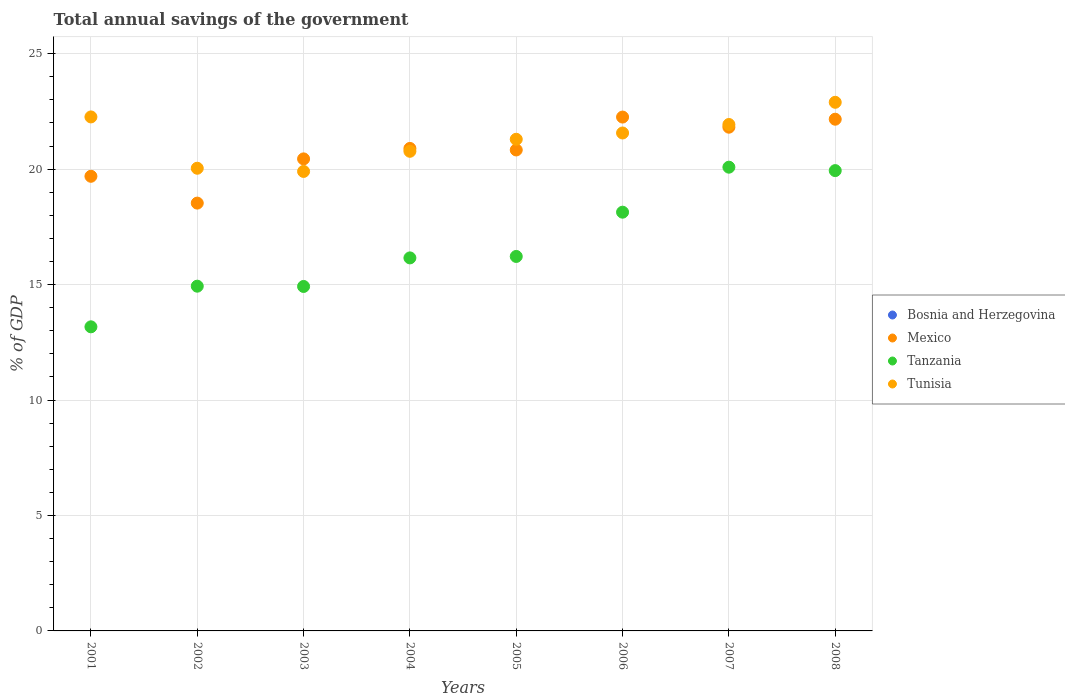How many different coloured dotlines are there?
Offer a terse response. 3. Is the number of dotlines equal to the number of legend labels?
Provide a succinct answer. No. What is the total annual savings of the government in Tanzania in 2004?
Keep it short and to the point. 16.16. Across all years, what is the maximum total annual savings of the government in Tunisia?
Your response must be concise. 22.89. Across all years, what is the minimum total annual savings of the government in Bosnia and Herzegovina?
Make the answer very short. 0. In which year was the total annual savings of the government in Mexico maximum?
Keep it short and to the point. 2006. What is the total total annual savings of the government in Tunisia in the graph?
Offer a very short reply. 170.66. What is the difference between the total annual savings of the government in Mexico in 2003 and that in 2004?
Keep it short and to the point. -0.45. What is the difference between the total annual savings of the government in Tanzania in 2002 and the total annual savings of the government in Mexico in 2001?
Make the answer very short. -4.76. What is the average total annual savings of the government in Mexico per year?
Your answer should be compact. 20.83. In the year 2006, what is the difference between the total annual savings of the government in Tanzania and total annual savings of the government in Tunisia?
Your response must be concise. -3.43. What is the ratio of the total annual savings of the government in Tunisia in 2007 to that in 2008?
Your response must be concise. 0.96. What is the difference between the highest and the second highest total annual savings of the government in Mexico?
Offer a terse response. 0.09. What is the difference between the highest and the lowest total annual savings of the government in Mexico?
Ensure brevity in your answer.  3.73. Is it the case that in every year, the sum of the total annual savings of the government in Mexico and total annual savings of the government in Tunisia  is greater than the total annual savings of the government in Tanzania?
Offer a very short reply. Yes. Is the total annual savings of the government in Tanzania strictly less than the total annual savings of the government in Tunisia over the years?
Provide a succinct answer. Yes. How many years are there in the graph?
Keep it short and to the point. 8. Are the values on the major ticks of Y-axis written in scientific E-notation?
Offer a terse response. No. Does the graph contain grids?
Your answer should be compact. Yes. Where does the legend appear in the graph?
Ensure brevity in your answer.  Center right. What is the title of the graph?
Ensure brevity in your answer.  Total annual savings of the government. Does "Caribbean small states" appear as one of the legend labels in the graph?
Your response must be concise. No. What is the label or title of the X-axis?
Your response must be concise. Years. What is the label or title of the Y-axis?
Make the answer very short. % of GDP. What is the % of GDP of Mexico in 2001?
Provide a succinct answer. 19.69. What is the % of GDP in Tanzania in 2001?
Your answer should be compact. 13.17. What is the % of GDP of Tunisia in 2001?
Make the answer very short. 22.26. What is the % of GDP in Bosnia and Herzegovina in 2002?
Give a very brief answer. 0. What is the % of GDP in Mexico in 2002?
Give a very brief answer. 18.53. What is the % of GDP in Tanzania in 2002?
Offer a terse response. 14.93. What is the % of GDP of Tunisia in 2002?
Your answer should be very brief. 20.04. What is the % of GDP of Bosnia and Herzegovina in 2003?
Your answer should be very brief. 0. What is the % of GDP of Mexico in 2003?
Offer a terse response. 20.44. What is the % of GDP of Tanzania in 2003?
Your answer should be compact. 14.92. What is the % of GDP in Tunisia in 2003?
Your response must be concise. 19.9. What is the % of GDP of Bosnia and Herzegovina in 2004?
Provide a short and direct response. 0. What is the % of GDP of Mexico in 2004?
Your response must be concise. 20.9. What is the % of GDP of Tanzania in 2004?
Your answer should be very brief. 16.16. What is the % of GDP in Tunisia in 2004?
Offer a very short reply. 20.77. What is the % of GDP in Bosnia and Herzegovina in 2005?
Your response must be concise. 0. What is the % of GDP in Mexico in 2005?
Give a very brief answer. 20.83. What is the % of GDP of Tanzania in 2005?
Ensure brevity in your answer.  16.22. What is the % of GDP of Tunisia in 2005?
Offer a very short reply. 21.29. What is the % of GDP of Bosnia and Herzegovina in 2006?
Provide a succinct answer. 0. What is the % of GDP in Mexico in 2006?
Your answer should be compact. 22.25. What is the % of GDP of Tanzania in 2006?
Provide a short and direct response. 18.13. What is the % of GDP of Tunisia in 2006?
Your answer should be very brief. 21.56. What is the % of GDP in Mexico in 2007?
Offer a very short reply. 21.82. What is the % of GDP in Tanzania in 2007?
Your response must be concise. 20.08. What is the % of GDP in Tunisia in 2007?
Provide a short and direct response. 21.93. What is the % of GDP of Mexico in 2008?
Offer a terse response. 22.16. What is the % of GDP in Tanzania in 2008?
Make the answer very short. 19.94. What is the % of GDP of Tunisia in 2008?
Provide a succinct answer. 22.89. Across all years, what is the maximum % of GDP of Mexico?
Your answer should be compact. 22.25. Across all years, what is the maximum % of GDP of Tanzania?
Your response must be concise. 20.08. Across all years, what is the maximum % of GDP in Tunisia?
Offer a very short reply. 22.89. Across all years, what is the minimum % of GDP of Mexico?
Give a very brief answer. 18.53. Across all years, what is the minimum % of GDP in Tanzania?
Provide a short and direct response. 13.17. Across all years, what is the minimum % of GDP in Tunisia?
Offer a very short reply. 19.9. What is the total % of GDP of Bosnia and Herzegovina in the graph?
Give a very brief answer. 0. What is the total % of GDP of Mexico in the graph?
Your answer should be very brief. 166.62. What is the total % of GDP of Tanzania in the graph?
Offer a very short reply. 133.55. What is the total % of GDP of Tunisia in the graph?
Your answer should be compact. 170.66. What is the difference between the % of GDP of Mexico in 2001 and that in 2002?
Your answer should be very brief. 1.16. What is the difference between the % of GDP in Tanzania in 2001 and that in 2002?
Your answer should be compact. -1.76. What is the difference between the % of GDP in Tunisia in 2001 and that in 2002?
Provide a short and direct response. 2.22. What is the difference between the % of GDP of Mexico in 2001 and that in 2003?
Make the answer very short. -0.75. What is the difference between the % of GDP in Tanzania in 2001 and that in 2003?
Your answer should be compact. -1.75. What is the difference between the % of GDP in Tunisia in 2001 and that in 2003?
Keep it short and to the point. 2.36. What is the difference between the % of GDP of Mexico in 2001 and that in 2004?
Keep it short and to the point. -1.21. What is the difference between the % of GDP of Tanzania in 2001 and that in 2004?
Provide a succinct answer. -2.99. What is the difference between the % of GDP of Tunisia in 2001 and that in 2004?
Offer a terse response. 1.49. What is the difference between the % of GDP in Mexico in 2001 and that in 2005?
Your answer should be very brief. -1.14. What is the difference between the % of GDP in Tanzania in 2001 and that in 2005?
Your answer should be very brief. -3.05. What is the difference between the % of GDP of Tunisia in 2001 and that in 2005?
Give a very brief answer. 0.97. What is the difference between the % of GDP of Mexico in 2001 and that in 2006?
Provide a succinct answer. -2.56. What is the difference between the % of GDP of Tanzania in 2001 and that in 2006?
Offer a terse response. -4.96. What is the difference between the % of GDP in Tunisia in 2001 and that in 2006?
Keep it short and to the point. 0.7. What is the difference between the % of GDP in Mexico in 2001 and that in 2007?
Your answer should be very brief. -2.13. What is the difference between the % of GDP in Tanzania in 2001 and that in 2007?
Your response must be concise. -6.91. What is the difference between the % of GDP in Tunisia in 2001 and that in 2007?
Your response must be concise. 0.33. What is the difference between the % of GDP of Mexico in 2001 and that in 2008?
Provide a short and direct response. -2.47. What is the difference between the % of GDP of Tanzania in 2001 and that in 2008?
Offer a very short reply. -6.77. What is the difference between the % of GDP of Tunisia in 2001 and that in 2008?
Offer a terse response. -0.63. What is the difference between the % of GDP of Mexico in 2002 and that in 2003?
Your answer should be very brief. -1.92. What is the difference between the % of GDP of Tanzania in 2002 and that in 2003?
Offer a very short reply. 0.01. What is the difference between the % of GDP of Tunisia in 2002 and that in 2003?
Offer a very short reply. 0.14. What is the difference between the % of GDP in Mexico in 2002 and that in 2004?
Provide a short and direct response. -2.37. What is the difference between the % of GDP in Tanzania in 2002 and that in 2004?
Your answer should be very brief. -1.22. What is the difference between the % of GDP of Tunisia in 2002 and that in 2004?
Make the answer very short. -0.73. What is the difference between the % of GDP in Mexico in 2002 and that in 2005?
Keep it short and to the point. -2.3. What is the difference between the % of GDP of Tanzania in 2002 and that in 2005?
Offer a very short reply. -1.29. What is the difference between the % of GDP in Tunisia in 2002 and that in 2005?
Offer a very short reply. -1.25. What is the difference between the % of GDP in Mexico in 2002 and that in 2006?
Give a very brief answer. -3.73. What is the difference between the % of GDP in Tanzania in 2002 and that in 2006?
Provide a short and direct response. -3.2. What is the difference between the % of GDP of Tunisia in 2002 and that in 2006?
Provide a short and direct response. -1.53. What is the difference between the % of GDP of Mexico in 2002 and that in 2007?
Offer a very short reply. -3.29. What is the difference between the % of GDP of Tanzania in 2002 and that in 2007?
Make the answer very short. -5.15. What is the difference between the % of GDP of Tunisia in 2002 and that in 2007?
Your response must be concise. -1.89. What is the difference between the % of GDP of Mexico in 2002 and that in 2008?
Ensure brevity in your answer.  -3.63. What is the difference between the % of GDP in Tanzania in 2002 and that in 2008?
Offer a terse response. -5.01. What is the difference between the % of GDP of Tunisia in 2002 and that in 2008?
Your response must be concise. -2.86. What is the difference between the % of GDP in Mexico in 2003 and that in 2004?
Keep it short and to the point. -0.45. What is the difference between the % of GDP of Tanzania in 2003 and that in 2004?
Offer a very short reply. -1.24. What is the difference between the % of GDP in Tunisia in 2003 and that in 2004?
Offer a terse response. -0.87. What is the difference between the % of GDP in Mexico in 2003 and that in 2005?
Offer a very short reply. -0.39. What is the difference between the % of GDP in Tanzania in 2003 and that in 2005?
Your answer should be compact. -1.3. What is the difference between the % of GDP in Tunisia in 2003 and that in 2005?
Your answer should be very brief. -1.39. What is the difference between the % of GDP of Mexico in 2003 and that in 2006?
Your answer should be compact. -1.81. What is the difference between the % of GDP of Tanzania in 2003 and that in 2006?
Provide a short and direct response. -3.22. What is the difference between the % of GDP in Tunisia in 2003 and that in 2006?
Offer a very short reply. -1.66. What is the difference between the % of GDP of Mexico in 2003 and that in 2007?
Provide a short and direct response. -1.37. What is the difference between the % of GDP of Tanzania in 2003 and that in 2007?
Your answer should be very brief. -5.17. What is the difference between the % of GDP of Tunisia in 2003 and that in 2007?
Provide a succinct answer. -2.03. What is the difference between the % of GDP of Mexico in 2003 and that in 2008?
Your response must be concise. -1.72. What is the difference between the % of GDP in Tanzania in 2003 and that in 2008?
Offer a terse response. -5.02. What is the difference between the % of GDP of Tunisia in 2003 and that in 2008?
Keep it short and to the point. -2.99. What is the difference between the % of GDP in Mexico in 2004 and that in 2005?
Your response must be concise. 0.07. What is the difference between the % of GDP of Tanzania in 2004 and that in 2005?
Your response must be concise. -0.06. What is the difference between the % of GDP of Tunisia in 2004 and that in 2005?
Provide a short and direct response. -0.52. What is the difference between the % of GDP in Mexico in 2004 and that in 2006?
Provide a succinct answer. -1.36. What is the difference between the % of GDP of Tanzania in 2004 and that in 2006?
Your answer should be very brief. -1.98. What is the difference between the % of GDP of Tunisia in 2004 and that in 2006?
Your response must be concise. -0.79. What is the difference between the % of GDP of Mexico in 2004 and that in 2007?
Provide a succinct answer. -0.92. What is the difference between the % of GDP of Tanzania in 2004 and that in 2007?
Offer a terse response. -3.93. What is the difference between the % of GDP in Tunisia in 2004 and that in 2007?
Ensure brevity in your answer.  -1.16. What is the difference between the % of GDP in Mexico in 2004 and that in 2008?
Your response must be concise. -1.27. What is the difference between the % of GDP in Tanzania in 2004 and that in 2008?
Your response must be concise. -3.78. What is the difference between the % of GDP in Tunisia in 2004 and that in 2008?
Your answer should be very brief. -2.12. What is the difference between the % of GDP of Mexico in 2005 and that in 2006?
Give a very brief answer. -1.42. What is the difference between the % of GDP in Tanzania in 2005 and that in 2006?
Keep it short and to the point. -1.92. What is the difference between the % of GDP of Tunisia in 2005 and that in 2006?
Provide a short and direct response. -0.27. What is the difference between the % of GDP of Mexico in 2005 and that in 2007?
Provide a succinct answer. -0.99. What is the difference between the % of GDP in Tanzania in 2005 and that in 2007?
Make the answer very short. -3.87. What is the difference between the % of GDP of Tunisia in 2005 and that in 2007?
Your response must be concise. -0.64. What is the difference between the % of GDP in Mexico in 2005 and that in 2008?
Provide a short and direct response. -1.33. What is the difference between the % of GDP in Tanzania in 2005 and that in 2008?
Your response must be concise. -3.72. What is the difference between the % of GDP in Tunisia in 2005 and that in 2008?
Offer a terse response. -1.6. What is the difference between the % of GDP in Mexico in 2006 and that in 2007?
Give a very brief answer. 0.44. What is the difference between the % of GDP in Tanzania in 2006 and that in 2007?
Provide a succinct answer. -1.95. What is the difference between the % of GDP of Tunisia in 2006 and that in 2007?
Give a very brief answer. -0.37. What is the difference between the % of GDP in Mexico in 2006 and that in 2008?
Offer a terse response. 0.09. What is the difference between the % of GDP in Tanzania in 2006 and that in 2008?
Ensure brevity in your answer.  -1.8. What is the difference between the % of GDP in Tunisia in 2006 and that in 2008?
Your answer should be compact. -1.33. What is the difference between the % of GDP of Mexico in 2007 and that in 2008?
Ensure brevity in your answer.  -0.35. What is the difference between the % of GDP in Tanzania in 2007 and that in 2008?
Your answer should be very brief. 0.15. What is the difference between the % of GDP in Tunisia in 2007 and that in 2008?
Offer a very short reply. -0.96. What is the difference between the % of GDP of Mexico in 2001 and the % of GDP of Tanzania in 2002?
Your answer should be very brief. 4.76. What is the difference between the % of GDP of Mexico in 2001 and the % of GDP of Tunisia in 2002?
Keep it short and to the point. -0.35. What is the difference between the % of GDP in Tanzania in 2001 and the % of GDP in Tunisia in 2002?
Your response must be concise. -6.87. What is the difference between the % of GDP of Mexico in 2001 and the % of GDP of Tanzania in 2003?
Keep it short and to the point. 4.77. What is the difference between the % of GDP in Mexico in 2001 and the % of GDP in Tunisia in 2003?
Provide a succinct answer. -0.21. What is the difference between the % of GDP in Tanzania in 2001 and the % of GDP in Tunisia in 2003?
Your answer should be compact. -6.73. What is the difference between the % of GDP in Mexico in 2001 and the % of GDP in Tanzania in 2004?
Ensure brevity in your answer.  3.53. What is the difference between the % of GDP of Mexico in 2001 and the % of GDP of Tunisia in 2004?
Make the answer very short. -1.08. What is the difference between the % of GDP in Tanzania in 2001 and the % of GDP in Tunisia in 2004?
Provide a short and direct response. -7.6. What is the difference between the % of GDP of Mexico in 2001 and the % of GDP of Tanzania in 2005?
Provide a succinct answer. 3.47. What is the difference between the % of GDP in Mexico in 2001 and the % of GDP in Tunisia in 2005?
Provide a short and direct response. -1.6. What is the difference between the % of GDP of Tanzania in 2001 and the % of GDP of Tunisia in 2005?
Keep it short and to the point. -8.12. What is the difference between the % of GDP of Mexico in 2001 and the % of GDP of Tanzania in 2006?
Offer a very short reply. 1.55. What is the difference between the % of GDP of Mexico in 2001 and the % of GDP of Tunisia in 2006?
Offer a terse response. -1.88. What is the difference between the % of GDP of Tanzania in 2001 and the % of GDP of Tunisia in 2006?
Keep it short and to the point. -8.39. What is the difference between the % of GDP in Mexico in 2001 and the % of GDP in Tanzania in 2007?
Offer a terse response. -0.39. What is the difference between the % of GDP in Mexico in 2001 and the % of GDP in Tunisia in 2007?
Your answer should be very brief. -2.24. What is the difference between the % of GDP in Tanzania in 2001 and the % of GDP in Tunisia in 2007?
Ensure brevity in your answer.  -8.76. What is the difference between the % of GDP of Mexico in 2001 and the % of GDP of Tanzania in 2008?
Your answer should be compact. -0.25. What is the difference between the % of GDP in Mexico in 2001 and the % of GDP in Tunisia in 2008?
Your response must be concise. -3.2. What is the difference between the % of GDP in Tanzania in 2001 and the % of GDP in Tunisia in 2008?
Your response must be concise. -9.72. What is the difference between the % of GDP of Mexico in 2002 and the % of GDP of Tanzania in 2003?
Keep it short and to the point. 3.61. What is the difference between the % of GDP in Mexico in 2002 and the % of GDP in Tunisia in 2003?
Keep it short and to the point. -1.37. What is the difference between the % of GDP of Tanzania in 2002 and the % of GDP of Tunisia in 2003?
Your response must be concise. -4.97. What is the difference between the % of GDP of Mexico in 2002 and the % of GDP of Tanzania in 2004?
Give a very brief answer. 2.37. What is the difference between the % of GDP in Mexico in 2002 and the % of GDP in Tunisia in 2004?
Offer a terse response. -2.24. What is the difference between the % of GDP in Tanzania in 2002 and the % of GDP in Tunisia in 2004?
Your answer should be compact. -5.84. What is the difference between the % of GDP of Mexico in 2002 and the % of GDP of Tanzania in 2005?
Offer a terse response. 2.31. What is the difference between the % of GDP of Mexico in 2002 and the % of GDP of Tunisia in 2005?
Your response must be concise. -2.76. What is the difference between the % of GDP in Tanzania in 2002 and the % of GDP in Tunisia in 2005?
Offer a terse response. -6.36. What is the difference between the % of GDP in Mexico in 2002 and the % of GDP in Tanzania in 2006?
Keep it short and to the point. 0.39. What is the difference between the % of GDP of Mexico in 2002 and the % of GDP of Tunisia in 2006?
Ensure brevity in your answer.  -3.04. What is the difference between the % of GDP in Tanzania in 2002 and the % of GDP in Tunisia in 2006?
Make the answer very short. -6.63. What is the difference between the % of GDP in Mexico in 2002 and the % of GDP in Tanzania in 2007?
Give a very brief answer. -1.56. What is the difference between the % of GDP in Mexico in 2002 and the % of GDP in Tunisia in 2007?
Provide a short and direct response. -3.4. What is the difference between the % of GDP of Tanzania in 2002 and the % of GDP of Tunisia in 2007?
Offer a very short reply. -7. What is the difference between the % of GDP in Mexico in 2002 and the % of GDP in Tanzania in 2008?
Provide a short and direct response. -1.41. What is the difference between the % of GDP of Mexico in 2002 and the % of GDP of Tunisia in 2008?
Give a very brief answer. -4.37. What is the difference between the % of GDP of Tanzania in 2002 and the % of GDP of Tunisia in 2008?
Provide a short and direct response. -7.96. What is the difference between the % of GDP of Mexico in 2003 and the % of GDP of Tanzania in 2004?
Keep it short and to the point. 4.29. What is the difference between the % of GDP of Mexico in 2003 and the % of GDP of Tunisia in 2004?
Your answer should be compact. -0.33. What is the difference between the % of GDP of Tanzania in 2003 and the % of GDP of Tunisia in 2004?
Give a very brief answer. -5.85. What is the difference between the % of GDP in Mexico in 2003 and the % of GDP in Tanzania in 2005?
Offer a terse response. 4.23. What is the difference between the % of GDP in Mexico in 2003 and the % of GDP in Tunisia in 2005?
Give a very brief answer. -0.85. What is the difference between the % of GDP of Tanzania in 2003 and the % of GDP of Tunisia in 2005?
Ensure brevity in your answer.  -6.37. What is the difference between the % of GDP in Mexico in 2003 and the % of GDP in Tanzania in 2006?
Your answer should be compact. 2.31. What is the difference between the % of GDP in Mexico in 2003 and the % of GDP in Tunisia in 2006?
Offer a terse response. -1.12. What is the difference between the % of GDP in Tanzania in 2003 and the % of GDP in Tunisia in 2006?
Ensure brevity in your answer.  -6.65. What is the difference between the % of GDP in Mexico in 2003 and the % of GDP in Tanzania in 2007?
Make the answer very short. 0.36. What is the difference between the % of GDP in Mexico in 2003 and the % of GDP in Tunisia in 2007?
Offer a terse response. -1.49. What is the difference between the % of GDP of Tanzania in 2003 and the % of GDP of Tunisia in 2007?
Your answer should be compact. -7.01. What is the difference between the % of GDP in Mexico in 2003 and the % of GDP in Tanzania in 2008?
Your response must be concise. 0.51. What is the difference between the % of GDP of Mexico in 2003 and the % of GDP of Tunisia in 2008?
Provide a succinct answer. -2.45. What is the difference between the % of GDP in Tanzania in 2003 and the % of GDP in Tunisia in 2008?
Keep it short and to the point. -7.98. What is the difference between the % of GDP in Mexico in 2004 and the % of GDP in Tanzania in 2005?
Offer a terse response. 4.68. What is the difference between the % of GDP of Mexico in 2004 and the % of GDP of Tunisia in 2005?
Your answer should be compact. -0.4. What is the difference between the % of GDP of Tanzania in 2004 and the % of GDP of Tunisia in 2005?
Give a very brief answer. -5.14. What is the difference between the % of GDP in Mexico in 2004 and the % of GDP in Tanzania in 2006?
Make the answer very short. 2.76. What is the difference between the % of GDP in Mexico in 2004 and the % of GDP in Tunisia in 2006?
Your response must be concise. -0.67. What is the difference between the % of GDP of Tanzania in 2004 and the % of GDP of Tunisia in 2006?
Make the answer very short. -5.41. What is the difference between the % of GDP in Mexico in 2004 and the % of GDP in Tanzania in 2007?
Your response must be concise. 0.81. What is the difference between the % of GDP in Mexico in 2004 and the % of GDP in Tunisia in 2007?
Offer a terse response. -1.04. What is the difference between the % of GDP of Tanzania in 2004 and the % of GDP of Tunisia in 2007?
Make the answer very short. -5.78. What is the difference between the % of GDP of Mexico in 2004 and the % of GDP of Tanzania in 2008?
Give a very brief answer. 0.96. What is the difference between the % of GDP of Mexico in 2004 and the % of GDP of Tunisia in 2008?
Provide a succinct answer. -2. What is the difference between the % of GDP in Tanzania in 2004 and the % of GDP in Tunisia in 2008?
Offer a terse response. -6.74. What is the difference between the % of GDP of Mexico in 2005 and the % of GDP of Tanzania in 2006?
Provide a succinct answer. 2.7. What is the difference between the % of GDP in Mexico in 2005 and the % of GDP in Tunisia in 2006?
Ensure brevity in your answer.  -0.73. What is the difference between the % of GDP of Tanzania in 2005 and the % of GDP of Tunisia in 2006?
Your answer should be compact. -5.35. What is the difference between the % of GDP in Mexico in 2005 and the % of GDP in Tanzania in 2007?
Provide a short and direct response. 0.75. What is the difference between the % of GDP of Mexico in 2005 and the % of GDP of Tunisia in 2007?
Keep it short and to the point. -1.1. What is the difference between the % of GDP of Tanzania in 2005 and the % of GDP of Tunisia in 2007?
Offer a terse response. -5.71. What is the difference between the % of GDP in Mexico in 2005 and the % of GDP in Tanzania in 2008?
Give a very brief answer. 0.89. What is the difference between the % of GDP of Mexico in 2005 and the % of GDP of Tunisia in 2008?
Give a very brief answer. -2.06. What is the difference between the % of GDP of Tanzania in 2005 and the % of GDP of Tunisia in 2008?
Offer a very short reply. -6.68. What is the difference between the % of GDP of Mexico in 2006 and the % of GDP of Tanzania in 2007?
Your answer should be compact. 2.17. What is the difference between the % of GDP of Mexico in 2006 and the % of GDP of Tunisia in 2007?
Offer a very short reply. 0.32. What is the difference between the % of GDP in Tanzania in 2006 and the % of GDP in Tunisia in 2007?
Your answer should be compact. -3.8. What is the difference between the % of GDP in Mexico in 2006 and the % of GDP in Tanzania in 2008?
Provide a succinct answer. 2.32. What is the difference between the % of GDP in Mexico in 2006 and the % of GDP in Tunisia in 2008?
Offer a very short reply. -0.64. What is the difference between the % of GDP in Tanzania in 2006 and the % of GDP in Tunisia in 2008?
Make the answer very short. -4.76. What is the difference between the % of GDP of Mexico in 2007 and the % of GDP of Tanzania in 2008?
Offer a very short reply. 1.88. What is the difference between the % of GDP in Mexico in 2007 and the % of GDP in Tunisia in 2008?
Offer a terse response. -1.08. What is the difference between the % of GDP of Tanzania in 2007 and the % of GDP of Tunisia in 2008?
Provide a succinct answer. -2.81. What is the average % of GDP in Mexico per year?
Offer a very short reply. 20.83. What is the average % of GDP in Tanzania per year?
Provide a short and direct response. 16.69. What is the average % of GDP of Tunisia per year?
Make the answer very short. 21.33. In the year 2001, what is the difference between the % of GDP in Mexico and % of GDP in Tanzania?
Give a very brief answer. 6.52. In the year 2001, what is the difference between the % of GDP of Mexico and % of GDP of Tunisia?
Your answer should be compact. -2.57. In the year 2001, what is the difference between the % of GDP in Tanzania and % of GDP in Tunisia?
Keep it short and to the point. -9.09. In the year 2002, what is the difference between the % of GDP of Mexico and % of GDP of Tanzania?
Your response must be concise. 3.6. In the year 2002, what is the difference between the % of GDP in Mexico and % of GDP in Tunisia?
Your answer should be very brief. -1.51. In the year 2002, what is the difference between the % of GDP in Tanzania and % of GDP in Tunisia?
Offer a terse response. -5.11. In the year 2003, what is the difference between the % of GDP of Mexico and % of GDP of Tanzania?
Give a very brief answer. 5.53. In the year 2003, what is the difference between the % of GDP of Mexico and % of GDP of Tunisia?
Ensure brevity in your answer.  0.54. In the year 2003, what is the difference between the % of GDP in Tanzania and % of GDP in Tunisia?
Make the answer very short. -4.98. In the year 2004, what is the difference between the % of GDP in Mexico and % of GDP in Tanzania?
Provide a short and direct response. 4.74. In the year 2004, what is the difference between the % of GDP of Mexico and % of GDP of Tunisia?
Your answer should be compact. 0.12. In the year 2004, what is the difference between the % of GDP of Tanzania and % of GDP of Tunisia?
Provide a short and direct response. -4.62. In the year 2005, what is the difference between the % of GDP in Mexico and % of GDP in Tanzania?
Your answer should be very brief. 4.61. In the year 2005, what is the difference between the % of GDP of Mexico and % of GDP of Tunisia?
Your response must be concise. -0.46. In the year 2005, what is the difference between the % of GDP of Tanzania and % of GDP of Tunisia?
Provide a succinct answer. -5.07. In the year 2006, what is the difference between the % of GDP of Mexico and % of GDP of Tanzania?
Your response must be concise. 4.12. In the year 2006, what is the difference between the % of GDP in Mexico and % of GDP in Tunisia?
Your answer should be compact. 0.69. In the year 2006, what is the difference between the % of GDP in Tanzania and % of GDP in Tunisia?
Give a very brief answer. -3.43. In the year 2007, what is the difference between the % of GDP of Mexico and % of GDP of Tanzania?
Offer a terse response. 1.73. In the year 2007, what is the difference between the % of GDP in Mexico and % of GDP in Tunisia?
Offer a terse response. -0.12. In the year 2007, what is the difference between the % of GDP in Tanzania and % of GDP in Tunisia?
Your answer should be very brief. -1.85. In the year 2008, what is the difference between the % of GDP in Mexico and % of GDP in Tanzania?
Provide a succinct answer. 2.23. In the year 2008, what is the difference between the % of GDP of Mexico and % of GDP of Tunisia?
Give a very brief answer. -0.73. In the year 2008, what is the difference between the % of GDP of Tanzania and % of GDP of Tunisia?
Your response must be concise. -2.96. What is the ratio of the % of GDP in Mexico in 2001 to that in 2002?
Keep it short and to the point. 1.06. What is the ratio of the % of GDP in Tanzania in 2001 to that in 2002?
Provide a short and direct response. 0.88. What is the ratio of the % of GDP of Tunisia in 2001 to that in 2002?
Offer a terse response. 1.11. What is the ratio of the % of GDP of Mexico in 2001 to that in 2003?
Your response must be concise. 0.96. What is the ratio of the % of GDP of Tanzania in 2001 to that in 2003?
Offer a terse response. 0.88. What is the ratio of the % of GDP in Tunisia in 2001 to that in 2003?
Your answer should be very brief. 1.12. What is the ratio of the % of GDP in Mexico in 2001 to that in 2004?
Your response must be concise. 0.94. What is the ratio of the % of GDP of Tanzania in 2001 to that in 2004?
Your answer should be very brief. 0.82. What is the ratio of the % of GDP of Tunisia in 2001 to that in 2004?
Ensure brevity in your answer.  1.07. What is the ratio of the % of GDP in Mexico in 2001 to that in 2005?
Your answer should be very brief. 0.95. What is the ratio of the % of GDP of Tanzania in 2001 to that in 2005?
Your response must be concise. 0.81. What is the ratio of the % of GDP of Tunisia in 2001 to that in 2005?
Provide a succinct answer. 1.05. What is the ratio of the % of GDP in Mexico in 2001 to that in 2006?
Provide a short and direct response. 0.88. What is the ratio of the % of GDP in Tanzania in 2001 to that in 2006?
Offer a very short reply. 0.73. What is the ratio of the % of GDP of Tunisia in 2001 to that in 2006?
Ensure brevity in your answer.  1.03. What is the ratio of the % of GDP of Mexico in 2001 to that in 2007?
Make the answer very short. 0.9. What is the ratio of the % of GDP of Tanzania in 2001 to that in 2007?
Your response must be concise. 0.66. What is the ratio of the % of GDP in Mexico in 2001 to that in 2008?
Your response must be concise. 0.89. What is the ratio of the % of GDP in Tanzania in 2001 to that in 2008?
Ensure brevity in your answer.  0.66. What is the ratio of the % of GDP in Tunisia in 2001 to that in 2008?
Your answer should be very brief. 0.97. What is the ratio of the % of GDP in Mexico in 2002 to that in 2003?
Give a very brief answer. 0.91. What is the ratio of the % of GDP of Mexico in 2002 to that in 2004?
Your answer should be very brief. 0.89. What is the ratio of the % of GDP in Tanzania in 2002 to that in 2004?
Make the answer very short. 0.92. What is the ratio of the % of GDP in Tunisia in 2002 to that in 2004?
Give a very brief answer. 0.96. What is the ratio of the % of GDP of Mexico in 2002 to that in 2005?
Your answer should be compact. 0.89. What is the ratio of the % of GDP of Tanzania in 2002 to that in 2005?
Ensure brevity in your answer.  0.92. What is the ratio of the % of GDP in Tunisia in 2002 to that in 2005?
Your answer should be compact. 0.94. What is the ratio of the % of GDP of Mexico in 2002 to that in 2006?
Keep it short and to the point. 0.83. What is the ratio of the % of GDP of Tanzania in 2002 to that in 2006?
Offer a terse response. 0.82. What is the ratio of the % of GDP of Tunisia in 2002 to that in 2006?
Keep it short and to the point. 0.93. What is the ratio of the % of GDP in Mexico in 2002 to that in 2007?
Your answer should be very brief. 0.85. What is the ratio of the % of GDP of Tanzania in 2002 to that in 2007?
Keep it short and to the point. 0.74. What is the ratio of the % of GDP in Tunisia in 2002 to that in 2007?
Provide a short and direct response. 0.91. What is the ratio of the % of GDP in Mexico in 2002 to that in 2008?
Ensure brevity in your answer.  0.84. What is the ratio of the % of GDP in Tanzania in 2002 to that in 2008?
Make the answer very short. 0.75. What is the ratio of the % of GDP of Tunisia in 2002 to that in 2008?
Make the answer very short. 0.88. What is the ratio of the % of GDP in Mexico in 2003 to that in 2004?
Provide a short and direct response. 0.98. What is the ratio of the % of GDP in Tanzania in 2003 to that in 2004?
Ensure brevity in your answer.  0.92. What is the ratio of the % of GDP of Tunisia in 2003 to that in 2004?
Make the answer very short. 0.96. What is the ratio of the % of GDP of Mexico in 2003 to that in 2005?
Provide a succinct answer. 0.98. What is the ratio of the % of GDP of Tanzania in 2003 to that in 2005?
Offer a terse response. 0.92. What is the ratio of the % of GDP of Tunisia in 2003 to that in 2005?
Your answer should be very brief. 0.93. What is the ratio of the % of GDP of Mexico in 2003 to that in 2006?
Make the answer very short. 0.92. What is the ratio of the % of GDP in Tanzania in 2003 to that in 2006?
Offer a very short reply. 0.82. What is the ratio of the % of GDP of Tunisia in 2003 to that in 2006?
Provide a succinct answer. 0.92. What is the ratio of the % of GDP in Mexico in 2003 to that in 2007?
Keep it short and to the point. 0.94. What is the ratio of the % of GDP of Tanzania in 2003 to that in 2007?
Give a very brief answer. 0.74. What is the ratio of the % of GDP of Tunisia in 2003 to that in 2007?
Give a very brief answer. 0.91. What is the ratio of the % of GDP of Mexico in 2003 to that in 2008?
Ensure brevity in your answer.  0.92. What is the ratio of the % of GDP in Tanzania in 2003 to that in 2008?
Make the answer very short. 0.75. What is the ratio of the % of GDP of Tunisia in 2003 to that in 2008?
Provide a short and direct response. 0.87. What is the ratio of the % of GDP in Tanzania in 2004 to that in 2005?
Provide a succinct answer. 1. What is the ratio of the % of GDP in Tunisia in 2004 to that in 2005?
Offer a terse response. 0.98. What is the ratio of the % of GDP in Mexico in 2004 to that in 2006?
Make the answer very short. 0.94. What is the ratio of the % of GDP of Tanzania in 2004 to that in 2006?
Ensure brevity in your answer.  0.89. What is the ratio of the % of GDP of Tunisia in 2004 to that in 2006?
Your response must be concise. 0.96. What is the ratio of the % of GDP in Mexico in 2004 to that in 2007?
Offer a terse response. 0.96. What is the ratio of the % of GDP of Tanzania in 2004 to that in 2007?
Provide a short and direct response. 0.8. What is the ratio of the % of GDP in Tunisia in 2004 to that in 2007?
Give a very brief answer. 0.95. What is the ratio of the % of GDP in Mexico in 2004 to that in 2008?
Make the answer very short. 0.94. What is the ratio of the % of GDP of Tanzania in 2004 to that in 2008?
Keep it short and to the point. 0.81. What is the ratio of the % of GDP of Tunisia in 2004 to that in 2008?
Your response must be concise. 0.91. What is the ratio of the % of GDP in Mexico in 2005 to that in 2006?
Offer a terse response. 0.94. What is the ratio of the % of GDP of Tanzania in 2005 to that in 2006?
Ensure brevity in your answer.  0.89. What is the ratio of the % of GDP in Tunisia in 2005 to that in 2006?
Provide a succinct answer. 0.99. What is the ratio of the % of GDP of Mexico in 2005 to that in 2007?
Offer a terse response. 0.95. What is the ratio of the % of GDP in Tanzania in 2005 to that in 2007?
Offer a terse response. 0.81. What is the ratio of the % of GDP in Tunisia in 2005 to that in 2007?
Give a very brief answer. 0.97. What is the ratio of the % of GDP in Mexico in 2005 to that in 2008?
Your answer should be compact. 0.94. What is the ratio of the % of GDP in Tanzania in 2005 to that in 2008?
Your answer should be compact. 0.81. What is the ratio of the % of GDP of Tunisia in 2005 to that in 2008?
Give a very brief answer. 0.93. What is the ratio of the % of GDP in Mexico in 2006 to that in 2007?
Your answer should be compact. 1.02. What is the ratio of the % of GDP in Tanzania in 2006 to that in 2007?
Provide a succinct answer. 0.9. What is the ratio of the % of GDP in Tunisia in 2006 to that in 2007?
Offer a terse response. 0.98. What is the ratio of the % of GDP in Tanzania in 2006 to that in 2008?
Your response must be concise. 0.91. What is the ratio of the % of GDP of Tunisia in 2006 to that in 2008?
Ensure brevity in your answer.  0.94. What is the ratio of the % of GDP of Mexico in 2007 to that in 2008?
Offer a terse response. 0.98. What is the ratio of the % of GDP in Tanzania in 2007 to that in 2008?
Your answer should be very brief. 1.01. What is the ratio of the % of GDP in Tunisia in 2007 to that in 2008?
Your response must be concise. 0.96. What is the difference between the highest and the second highest % of GDP in Mexico?
Give a very brief answer. 0.09. What is the difference between the highest and the second highest % of GDP of Tanzania?
Offer a terse response. 0.15. What is the difference between the highest and the second highest % of GDP of Tunisia?
Provide a succinct answer. 0.63. What is the difference between the highest and the lowest % of GDP in Mexico?
Your answer should be very brief. 3.73. What is the difference between the highest and the lowest % of GDP in Tanzania?
Offer a very short reply. 6.91. What is the difference between the highest and the lowest % of GDP of Tunisia?
Make the answer very short. 2.99. 